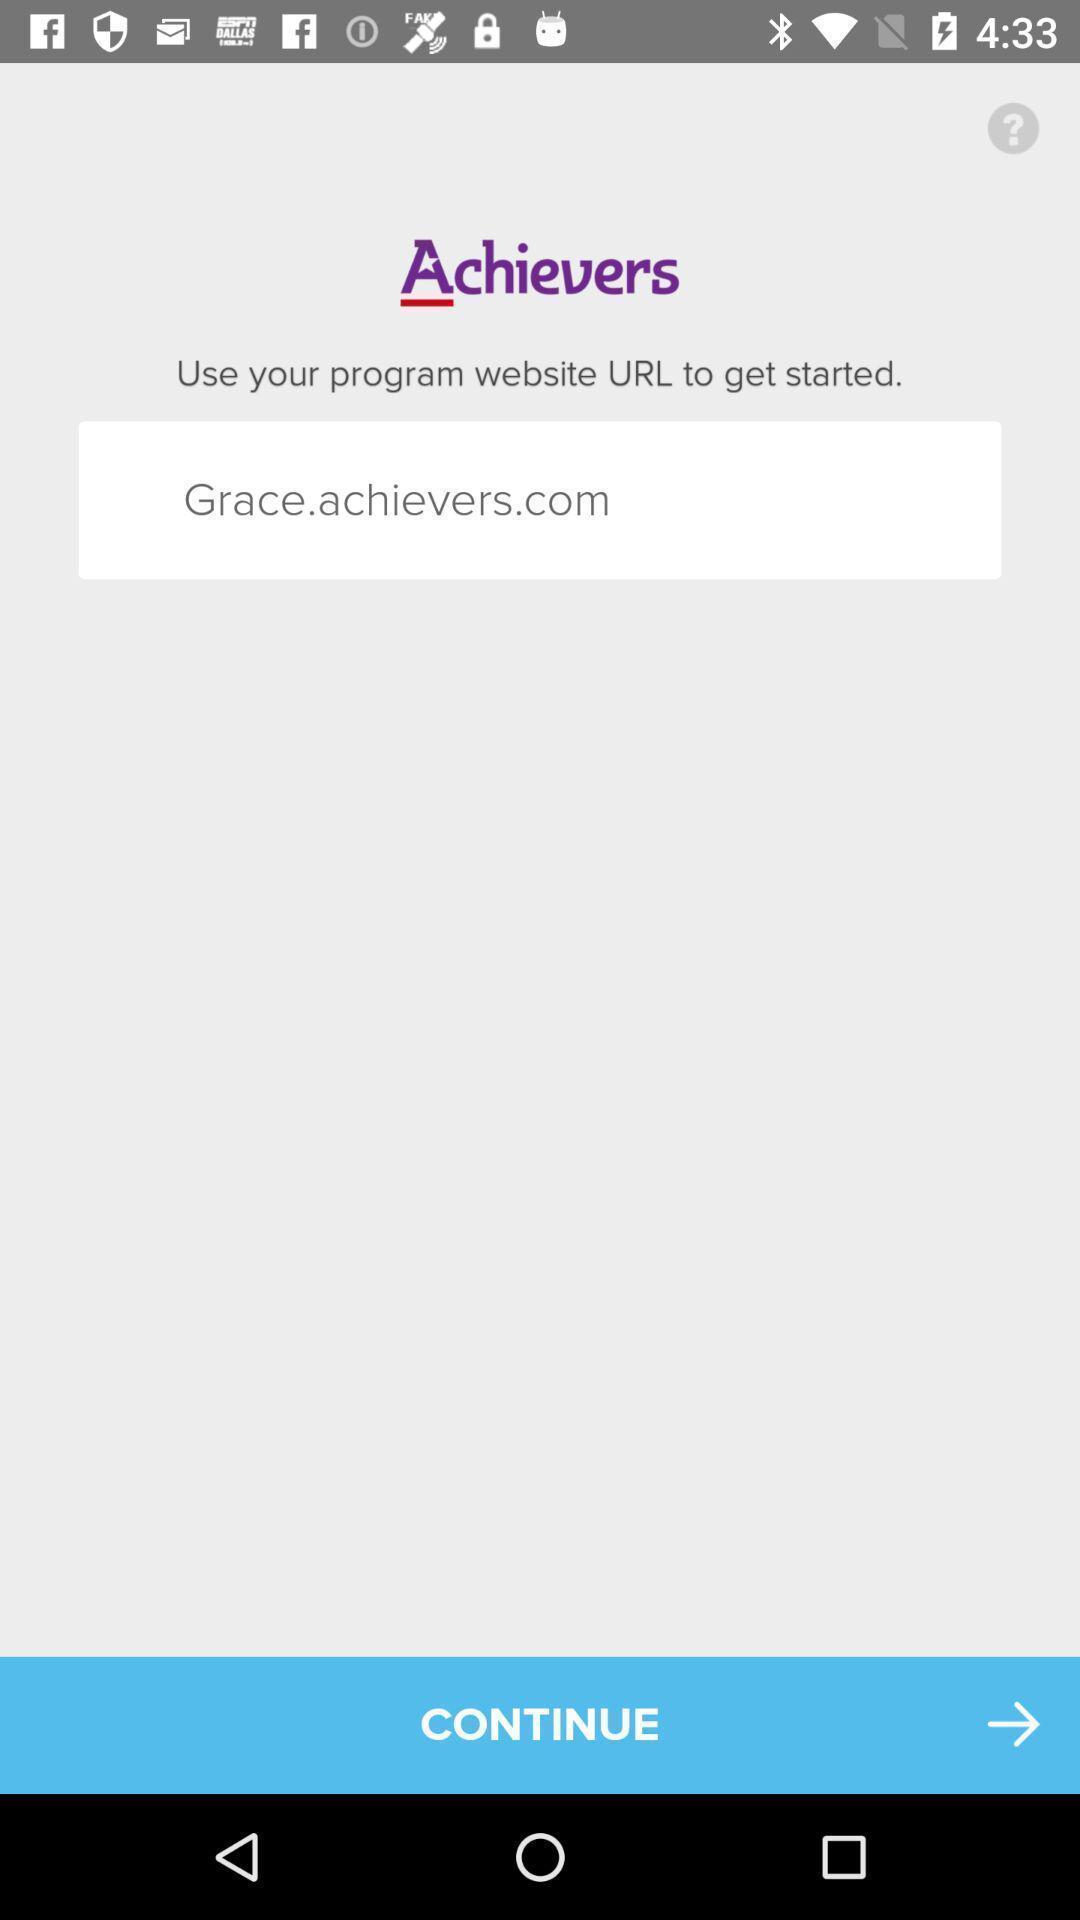Provide a textual representation of this image. Welcome page of an achievers app. 